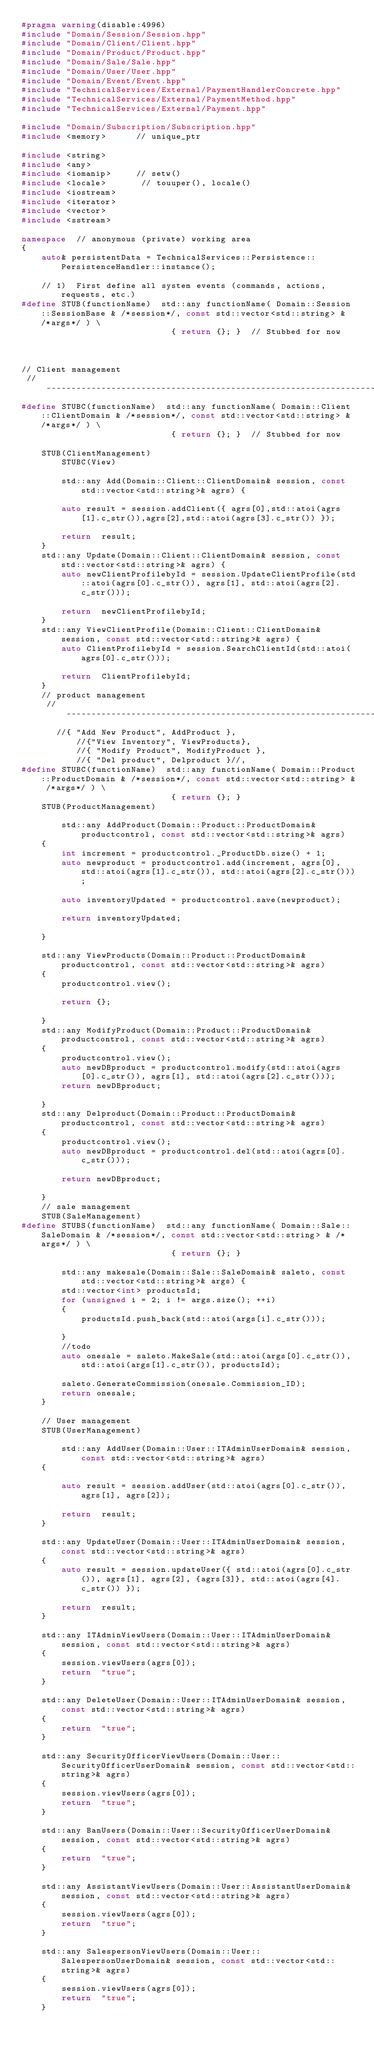Convert code to text. <code><loc_0><loc_0><loc_500><loc_500><_C++_>#pragma warning(disable:4996)
#include "Domain/Session/Session.hpp"
#include "Domain/Client/Client.hpp"
#include "Domain/Product/Product.hpp"
#include "Domain/Sale/Sale.hpp"
#include "Domain/User/User.hpp"
#include "Domain/Event/Event.hpp"
#include "TechnicalServices/External/PaymentHandlerConcrete.hpp"
#include "TechnicalServices/External/PaymentMethod.hpp"
#include "TechnicalServices/External/Payment.hpp"

#include "Domain/Subscription/Subscription.hpp"
#include <memory>      // unique_ptr

#include <string>
#include <any>
#include <iomanip>     // setw()
#include <locale>       // touuper(), locale()
#include <iostream>
#include <iterator>
#include <vector>
#include <sstream>

namespace  // anonymous (private) working area
{
    auto& persistentData = TechnicalServices::Persistence::PersistenceHandler::instance();

    // 1)  First define all system events (commands, actions, requests, etc.)
#define STUB(functionName)  std::any functionName( Domain::Session::SessionBase & /*session*/, const std::vector<std::string> & /*args*/ ) \
                              { return {}; }  // Stubbed for now



// Client management  
 //---------------------------------------------------------------------------------
#define STUBC(functionName)  std::any functionName( Domain::Client::ClientDomain & /*session*/, const std::vector<std::string> & /*args*/ ) \
                              { return {}; }  // Stubbed for now

    STUB(ClientManagement)
        STUBC(View)

        std::any Add(Domain::Client::ClientDomain& session, const std::vector<std::string>& agrs) {

        auto result = session.addClient({ agrs[0],std::atoi(agrs[1].c_str()),agrs[2],std::atoi(agrs[3].c_str()) });

        return  result;
    }
    std::any Update(Domain::Client::ClientDomain& session, const std::vector<std::string>& agrs) {
        auto newClientProfilebyId = session.UpdateClientProfile(std::atoi(agrs[0].c_str()), agrs[1], std::atoi(agrs[2].c_str()));

        return  newClientProfilebyId;
    }
    std::any ViewClientProfile(Domain::Client::ClientDomain& session, const std::vector<std::string>& agrs) {
        auto ClientProfilebyId = session.SearchClientId(std::atoi(agrs[0].c_str()));

        return  ClientProfilebyId;
    }
    // product management 
     //---------------------------------------------------------------------------------
       //{ "Add New Product", AddProduct },
           //{"View Inventory", ViewProducts},
           //{ "Modify Product", ModifyProduct },
           //{ "Del product", Delproduct }//,
#define STUBC(functionName)  std::any functionName( Domain::Product::ProductDomain & /*session*/, const std::vector<std::string> & /*args*/ ) \
                              { return {}; }  
    STUB(ProductManagement)

        std::any AddProduct(Domain::Product::ProductDomain& productcontrol, const std::vector<std::string>& agrs)
    {
        int increment = productcontrol._ProductDb.size() + 1;
        auto newproduct = productcontrol.add(increment, agrs[0], std::atoi(agrs[1].c_str()), std::atoi(agrs[2].c_str()));

        auto inventoryUpdated = productcontrol.save(newproduct);

        return inventoryUpdated;

    }

    std::any ViewProducts(Domain::Product::ProductDomain& productcontrol, const std::vector<std::string>& agrs)
    {
        productcontrol.view();

        return {};

    }
    std::any ModifyProduct(Domain::Product::ProductDomain& productcontrol, const std::vector<std::string>& agrs)
    {
        productcontrol.view();
        auto newDBproduct = productcontrol.modify(std::atoi(agrs[0].c_str()), agrs[1], std::atoi(agrs[2].c_str()));
        return newDBproduct;

    }
    std::any Delproduct(Domain::Product::ProductDomain& productcontrol, const std::vector<std::string>& agrs)
    {
        productcontrol.view();
        auto newDBproduct = productcontrol.del(std::atoi(agrs[0].c_str()));

        return newDBproduct;

    }
    // sale management 
    STUB(SaleManagement)
#define STUBS(functionName)  std::any functionName( Domain::Sale::SaleDomain & /*session*/, const std::vector<std::string> & /*args*/ ) \
                              { return {}; }  

        std::any makesale(Domain::Sale::SaleDomain& saleto, const std::vector<std::string>& args) {
        std::vector<int> productsId;
        for (unsigned i = 2; i != args.size(); ++i)
        {
            productsId.push_back(std::atoi(args[i].c_str()));

        }
        //todo
        auto onesale = saleto.MakeSale(std::atoi(args[0].c_str()), std::atoi(args[1].c_str()), productsId);

        saleto.GenerateCommission(onesale.Commission_ID);
        return onesale;
    }

    // User management
    STUB(UserManagement)

        std::any AddUser(Domain::User::ITAdminUserDomain& session, const std::vector<std::string>& agrs)
    {

        auto result = session.addUser(std::atoi(agrs[0].c_str()), agrs[1], agrs[2]);

        return  result;
    }

    std::any UpdateUser(Domain::User::ITAdminUserDomain& session, const std::vector<std::string>& agrs)
    {
        auto result = session.updateUser({ std::atoi(agrs[0].c_str()), agrs[1], agrs[2], {agrs[3]}, std::atoi(agrs[4].c_str()) });

        return  result;
    }

    std::any ITAdminViewUsers(Domain::User::ITAdminUserDomain& session, const std::vector<std::string>& agrs)
    {
        session.viewUsers(agrs[0]);
        return  "true";
    }

    std::any DeleteUser(Domain::User::ITAdminUserDomain& session, const std::vector<std::string>& agrs)
    {
        return  "true";
    }

    std::any SecurityOfficerViewUsers(Domain::User::SecurityOfficerUserDomain& session, const std::vector<std::string>& agrs)
    {
        session.viewUsers(agrs[0]);
        return  "true";
    }

    std::any BanUsers(Domain::User::SecurityOfficerUserDomain& session, const std::vector<std::string>& agrs)
    {
        return  "true";
    }

    std::any AssistantViewUsers(Domain::User::AssistantUserDomain& session, const std::vector<std::string>& agrs)
    {
        session.viewUsers(agrs[0]);
        return  "true";
    }

    std::any SalespersonViewUsers(Domain::User::SalespersonUserDomain& session, const std::vector<std::string>& agrs)
    {
        session.viewUsers(agrs[0]);
        return  "true";
    }
</code> 